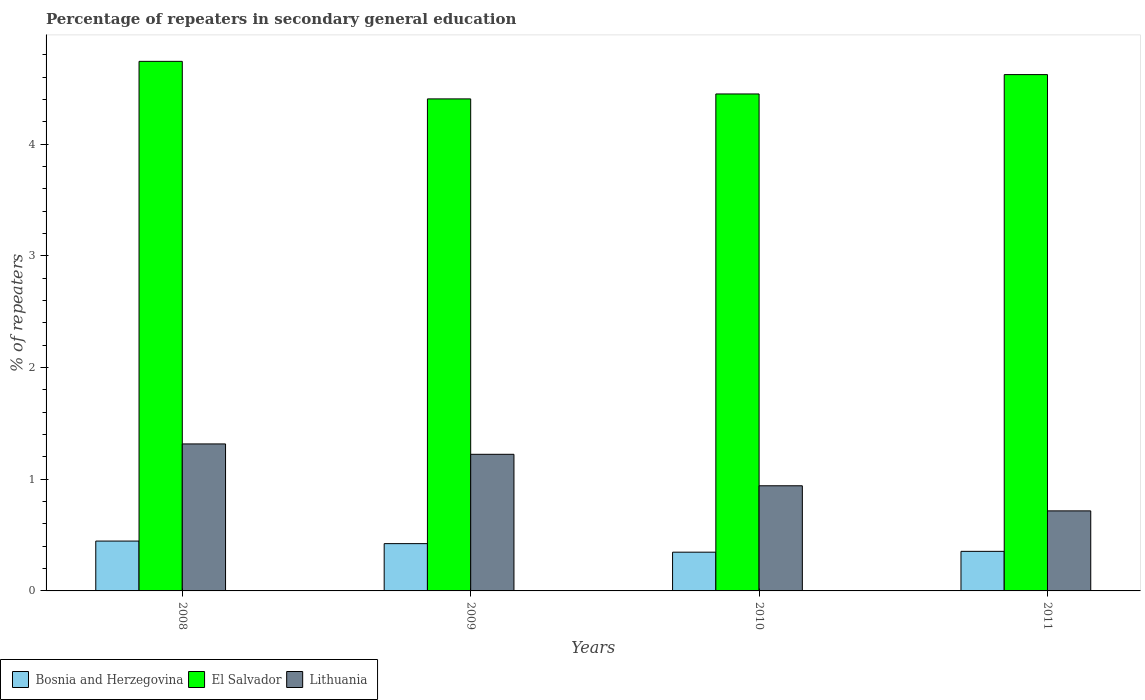How many different coloured bars are there?
Give a very brief answer. 3. Are the number of bars per tick equal to the number of legend labels?
Provide a succinct answer. Yes. Are the number of bars on each tick of the X-axis equal?
Your response must be concise. Yes. How many bars are there on the 1st tick from the right?
Keep it short and to the point. 3. What is the label of the 1st group of bars from the left?
Provide a short and direct response. 2008. In how many cases, is the number of bars for a given year not equal to the number of legend labels?
Offer a terse response. 0. What is the percentage of repeaters in secondary general education in El Salvador in 2010?
Your response must be concise. 4.45. Across all years, what is the maximum percentage of repeaters in secondary general education in El Salvador?
Provide a succinct answer. 4.74. Across all years, what is the minimum percentage of repeaters in secondary general education in Bosnia and Herzegovina?
Your response must be concise. 0.35. In which year was the percentage of repeaters in secondary general education in Bosnia and Herzegovina minimum?
Keep it short and to the point. 2010. What is the total percentage of repeaters in secondary general education in Lithuania in the graph?
Keep it short and to the point. 4.2. What is the difference between the percentage of repeaters in secondary general education in El Salvador in 2008 and that in 2009?
Offer a very short reply. 0.34. What is the difference between the percentage of repeaters in secondary general education in Bosnia and Herzegovina in 2011 and the percentage of repeaters in secondary general education in El Salvador in 2010?
Keep it short and to the point. -4.09. What is the average percentage of repeaters in secondary general education in Lithuania per year?
Provide a succinct answer. 1.05. In the year 2010, what is the difference between the percentage of repeaters in secondary general education in Bosnia and Herzegovina and percentage of repeaters in secondary general education in Lithuania?
Keep it short and to the point. -0.59. What is the ratio of the percentage of repeaters in secondary general education in Lithuania in 2009 to that in 2011?
Your answer should be very brief. 1.71. Is the difference between the percentage of repeaters in secondary general education in Bosnia and Herzegovina in 2010 and 2011 greater than the difference between the percentage of repeaters in secondary general education in Lithuania in 2010 and 2011?
Your answer should be compact. No. What is the difference between the highest and the second highest percentage of repeaters in secondary general education in Bosnia and Herzegovina?
Provide a succinct answer. 0.02. What is the difference between the highest and the lowest percentage of repeaters in secondary general education in El Salvador?
Make the answer very short. 0.34. Is the sum of the percentage of repeaters in secondary general education in El Salvador in 2009 and 2010 greater than the maximum percentage of repeaters in secondary general education in Lithuania across all years?
Your response must be concise. Yes. What does the 2nd bar from the left in 2008 represents?
Your response must be concise. El Salvador. What does the 2nd bar from the right in 2010 represents?
Provide a short and direct response. El Salvador. How many bars are there?
Give a very brief answer. 12. Are the values on the major ticks of Y-axis written in scientific E-notation?
Your answer should be very brief. No. Does the graph contain any zero values?
Your answer should be very brief. No. Where does the legend appear in the graph?
Your response must be concise. Bottom left. How many legend labels are there?
Offer a very short reply. 3. How are the legend labels stacked?
Provide a succinct answer. Horizontal. What is the title of the graph?
Offer a very short reply. Percentage of repeaters in secondary general education. What is the label or title of the X-axis?
Ensure brevity in your answer.  Years. What is the label or title of the Y-axis?
Your response must be concise. % of repeaters. What is the % of repeaters in Bosnia and Herzegovina in 2008?
Make the answer very short. 0.45. What is the % of repeaters of El Salvador in 2008?
Your answer should be very brief. 4.74. What is the % of repeaters in Lithuania in 2008?
Provide a succinct answer. 1.32. What is the % of repeaters in Bosnia and Herzegovina in 2009?
Provide a succinct answer. 0.42. What is the % of repeaters of El Salvador in 2009?
Your response must be concise. 4.4. What is the % of repeaters in Lithuania in 2009?
Your answer should be very brief. 1.22. What is the % of repeaters of Bosnia and Herzegovina in 2010?
Keep it short and to the point. 0.35. What is the % of repeaters in El Salvador in 2010?
Make the answer very short. 4.45. What is the % of repeaters of Lithuania in 2010?
Your answer should be compact. 0.94. What is the % of repeaters of Bosnia and Herzegovina in 2011?
Ensure brevity in your answer.  0.35. What is the % of repeaters in El Salvador in 2011?
Your answer should be compact. 4.62. What is the % of repeaters of Lithuania in 2011?
Your answer should be compact. 0.72. Across all years, what is the maximum % of repeaters of Bosnia and Herzegovina?
Provide a short and direct response. 0.45. Across all years, what is the maximum % of repeaters of El Salvador?
Offer a terse response. 4.74. Across all years, what is the maximum % of repeaters of Lithuania?
Your answer should be very brief. 1.32. Across all years, what is the minimum % of repeaters in Bosnia and Herzegovina?
Your response must be concise. 0.35. Across all years, what is the minimum % of repeaters in El Salvador?
Provide a succinct answer. 4.4. Across all years, what is the minimum % of repeaters of Lithuania?
Make the answer very short. 0.72. What is the total % of repeaters in Bosnia and Herzegovina in the graph?
Offer a terse response. 1.57. What is the total % of repeaters of El Salvador in the graph?
Give a very brief answer. 18.22. What is the total % of repeaters in Lithuania in the graph?
Your answer should be compact. 4.2. What is the difference between the % of repeaters in Bosnia and Herzegovina in 2008 and that in 2009?
Offer a very short reply. 0.02. What is the difference between the % of repeaters of El Salvador in 2008 and that in 2009?
Offer a terse response. 0.34. What is the difference between the % of repeaters of Lithuania in 2008 and that in 2009?
Your response must be concise. 0.09. What is the difference between the % of repeaters in Bosnia and Herzegovina in 2008 and that in 2010?
Make the answer very short. 0.1. What is the difference between the % of repeaters of El Salvador in 2008 and that in 2010?
Offer a very short reply. 0.29. What is the difference between the % of repeaters of Lithuania in 2008 and that in 2010?
Your answer should be very brief. 0.37. What is the difference between the % of repeaters in Bosnia and Herzegovina in 2008 and that in 2011?
Your answer should be very brief. 0.09. What is the difference between the % of repeaters in El Salvador in 2008 and that in 2011?
Make the answer very short. 0.12. What is the difference between the % of repeaters of Lithuania in 2008 and that in 2011?
Provide a succinct answer. 0.6. What is the difference between the % of repeaters in Bosnia and Herzegovina in 2009 and that in 2010?
Provide a short and direct response. 0.08. What is the difference between the % of repeaters in El Salvador in 2009 and that in 2010?
Your answer should be compact. -0.04. What is the difference between the % of repeaters of Lithuania in 2009 and that in 2010?
Offer a terse response. 0.28. What is the difference between the % of repeaters in Bosnia and Herzegovina in 2009 and that in 2011?
Make the answer very short. 0.07. What is the difference between the % of repeaters of El Salvador in 2009 and that in 2011?
Keep it short and to the point. -0.22. What is the difference between the % of repeaters of Lithuania in 2009 and that in 2011?
Make the answer very short. 0.51. What is the difference between the % of repeaters in Bosnia and Herzegovina in 2010 and that in 2011?
Your answer should be very brief. -0.01. What is the difference between the % of repeaters of El Salvador in 2010 and that in 2011?
Your answer should be compact. -0.17. What is the difference between the % of repeaters in Lithuania in 2010 and that in 2011?
Your answer should be very brief. 0.22. What is the difference between the % of repeaters of Bosnia and Herzegovina in 2008 and the % of repeaters of El Salvador in 2009?
Keep it short and to the point. -3.96. What is the difference between the % of repeaters of Bosnia and Herzegovina in 2008 and the % of repeaters of Lithuania in 2009?
Ensure brevity in your answer.  -0.78. What is the difference between the % of repeaters in El Salvador in 2008 and the % of repeaters in Lithuania in 2009?
Ensure brevity in your answer.  3.52. What is the difference between the % of repeaters of Bosnia and Herzegovina in 2008 and the % of repeaters of El Salvador in 2010?
Your response must be concise. -4. What is the difference between the % of repeaters of Bosnia and Herzegovina in 2008 and the % of repeaters of Lithuania in 2010?
Give a very brief answer. -0.49. What is the difference between the % of repeaters of El Salvador in 2008 and the % of repeaters of Lithuania in 2010?
Provide a succinct answer. 3.8. What is the difference between the % of repeaters in Bosnia and Herzegovina in 2008 and the % of repeaters in El Salvador in 2011?
Make the answer very short. -4.18. What is the difference between the % of repeaters of Bosnia and Herzegovina in 2008 and the % of repeaters of Lithuania in 2011?
Provide a short and direct response. -0.27. What is the difference between the % of repeaters of El Salvador in 2008 and the % of repeaters of Lithuania in 2011?
Offer a very short reply. 4.02. What is the difference between the % of repeaters of Bosnia and Herzegovina in 2009 and the % of repeaters of El Salvador in 2010?
Make the answer very short. -4.03. What is the difference between the % of repeaters of Bosnia and Herzegovina in 2009 and the % of repeaters of Lithuania in 2010?
Your response must be concise. -0.52. What is the difference between the % of repeaters in El Salvador in 2009 and the % of repeaters in Lithuania in 2010?
Provide a short and direct response. 3.46. What is the difference between the % of repeaters of Bosnia and Herzegovina in 2009 and the % of repeaters of El Salvador in 2011?
Give a very brief answer. -4.2. What is the difference between the % of repeaters of Bosnia and Herzegovina in 2009 and the % of repeaters of Lithuania in 2011?
Offer a very short reply. -0.29. What is the difference between the % of repeaters in El Salvador in 2009 and the % of repeaters in Lithuania in 2011?
Offer a very short reply. 3.69. What is the difference between the % of repeaters in Bosnia and Herzegovina in 2010 and the % of repeaters in El Salvador in 2011?
Keep it short and to the point. -4.28. What is the difference between the % of repeaters in Bosnia and Herzegovina in 2010 and the % of repeaters in Lithuania in 2011?
Offer a terse response. -0.37. What is the difference between the % of repeaters in El Salvador in 2010 and the % of repeaters in Lithuania in 2011?
Keep it short and to the point. 3.73. What is the average % of repeaters of Bosnia and Herzegovina per year?
Give a very brief answer. 0.39. What is the average % of repeaters in El Salvador per year?
Offer a terse response. 4.55. What is the average % of repeaters of Lithuania per year?
Offer a terse response. 1.05. In the year 2008, what is the difference between the % of repeaters of Bosnia and Herzegovina and % of repeaters of El Salvador?
Provide a succinct answer. -4.29. In the year 2008, what is the difference between the % of repeaters of Bosnia and Herzegovina and % of repeaters of Lithuania?
Give a very brief answer. -0.87. In the year 2008, what is the difference between the % of repeaters of El Salvador and % of repeaters of Lithuania?
Ensure brevity in your answer.  3.43. In the year 2009, what is the difference between the % of repeaters in Bosnia and Herzegovina and % of repeaters in El Salvador?
Provide a succinct answer. -3.98. In the year 2009, what is the difference between the % of repeaters in Bosnia and Herzegovina and % of repeaters in Lithuania?
Provide a short and direct response. -0.8. In the year 2009, what is the difference between the % of repeaters of El Salvador and % of repeaters of Lithuania?
Your answer should be compact. 3.18. In the year 2010, what is the difference between the % of repeaters of Bosnia and Herzegovina and % of repeaters of El Salvador?
Provide a short and direct response. -4.1. In the year 2010, what is the difference between the % of repeaters in Bosnia and Herzegovina and % of repeaters in Lithuania?
Make the answer very short. -0.59. In the year 2010, what is the difference between the % of repeaters of El Salvador and % of repeaters of Lithuania?
Provide a succinct answer. 3.51. In the year 2011, what is the difference between the % of repeaters of Bosnia and Herzegovina and % of repeaters of El Salvador?
Your response must be concise. -4.27. In the year 2011, what is the difference between the % of repeaters in Bosnia and Herzegovina and % of repeaters in Lithuania?
Give a very brief answer. -0.36. In the year 2011, what is the difference between the % of repeaters in El Salvador and % of repeaters in Lithuania?
Make the answer very short. 3.91. What is the ratio of the % of repeaters in Bosnia and Herzegovina in 2008 to that in 2009?
Keep it short and to the point. 1.05. What is the ratio of the % of repeaters in El Salvador in 2008 to that in 2009?
Ensure brevity in your answer.  1.08. What is the ratio of the % of repeaters of Lithuania in 2008 to that in 2009?
Offer a terse response. 1.08. What is the ratio of the % of repeaters of Bosnia and Herzegovina in 2008 to that in 2010?
Your answer should be compact. 1.29. What is the ratio of the % of repeaters in El Salvador in 2008 to that in 2010?
Offer a terse response. 1.07. What is the ratio of the % of repeaters of Lithuania in 2008 to that in 2010?
Offer a very short reply. 1.4. What is the ratio of the % of repeaters of Bosnia and Herzegovina in 2008 to that in 2011?
Provide a succinct answer. 1.26. What is the ratio of the % of repeaters of El Salvador in 2008 to that in 2011?
Offer a very short reply. 1.03. What is the ratio of the % of repeaters in Lithuania in 2008 to that in 2011?
Provide a short and direct response. 1.84. What is the ratio of the % of repeaters in Bosnia and Herzegovina in 2009 to that in 2010?
Your response must be concise. 1.22. What is the ratio of the % of repeaters of El Salvador in 2009 to that in 2010?
Your answer should be compact. 0.99. What is the ratio of the % of repeaters of Lithuania in 2009 to that in 2010?
Keep it short and to the point. 1.3. What is the ratio of the % of repeaters of Bosnia and Herzegovina in 2009 to that in 2011?
Offer a terse response. 1.2. What is the ratio of the % of repeaters in El Salvador in 2009 to that in 2011?
Make the answer very short. 0.95. What is the ratio of the % of repeaters in Lithuania in 2009 to that in 2011?
Give a very brief answer. 1.71. What is the ratio of the % of repeaters of Bosnia and Herzegovina in 2010 to that in 2011?
Your answer should be compact. 0.98. What is the ratio of the % of repeaters in El Salvador in 2010 to that in 2011?
Provide a short and direct response. 0.96. What is the ratio of the % of repeaters in Lithuania in 2010 to that in 2011?
Give a very brief answer. 1.31. What is the difference between the highest and the second highest % of repeaters in Bosnia and Herzegovina?
Your response must be concise. 0.02. What is the difference between the highest and the second highest % of repeaters of El Salvador?
Offer a very short reply. 0.12. What is the difference between the highest and the second highest % of repeaters of Lithuania?
Offer a terse response. 0.09. What is the difference between the highest and the lowest % of repeaters in Bosnia and Herzegovina?
Give a very brief answer. 0.1. What is the difference between the highest and the lowest % of repeaters of El Salvador?
Offer a very short reply. 0.34. What is the difference between the highest and the lowest % of repeaters of Lithuania?
Ensure brevity in your answer.  0.6. 